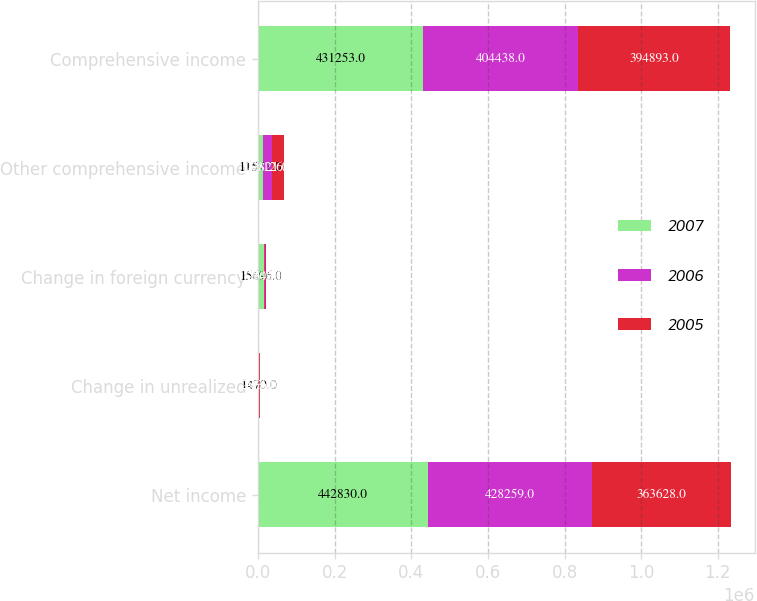Convert chart. <chart><loc_0><loc_0><loc_500><loc_500><stacked_bar_chart><ecel><fcel>Net income<fcel>Change in unrealized<fcel>Change in foreign currency<fcel>Other comprehensive income<fcel>Comprehensive income<nl><fcel>2007<fcel>442830<fcel>1470<fcel>15696<fcel>11577<fcel>431253<nl><fcel>2006<fcel>428259<fcel>143<fcel>2503<fcel>23821<fcel>404438<nl><fcel>2005<fcel>363628<fcel>2536<fcel>2040<fcel>31265<fcel>394893<nl></chart> 